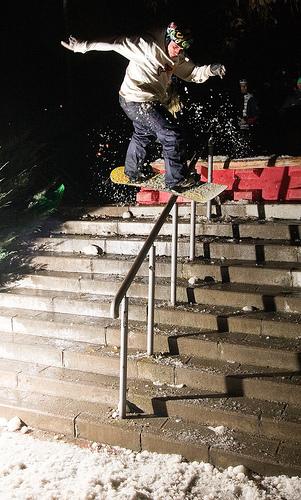Is the man skiing?
Write a very short answer. No. What is the man doing?
Keep it brief. Snowboarding. How many steps of stairs are there?
Write a very short answer. 10. 